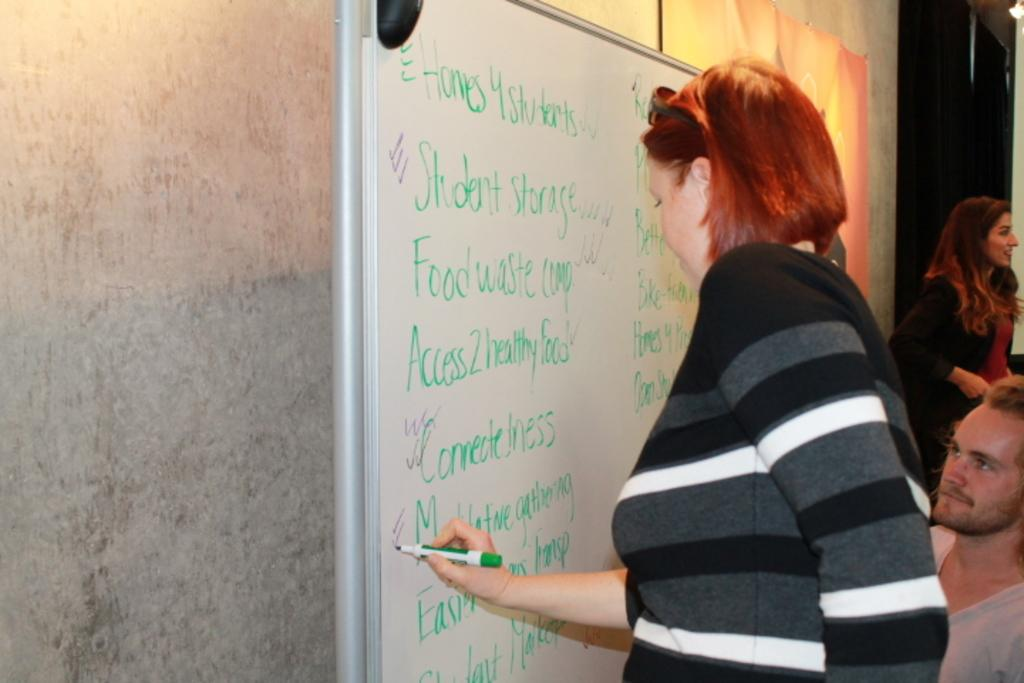<image>
Describe the image concisely. A woman is marking a list of items that includes student storage. 